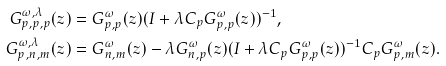Convert formula to latex. <formula><loc_0><loc_0><loc_500><loc_500>G ^ { \omega , \lambda } _ { p , p , p } ( z ) & = G ^ { \omega } _ { p , p } ( z ) ( I + \lambda C _ { p } G ^ { \omega } _ { p , p } ( z ) ) ^ { - 1 } , \\ G ^ { \omega , \lambda } _ { p , n , m } ( z ) & = G ^ { \omega } _ { n , m } ( z ) - \lambda G ^ { \omega } _ { n , p } ( z ) ( I + \lambda C _ { p } G ^ { \omega } _ { p , p } ( z ) ) ^ { - 1 } C _ { p } G ^ { \omega } _ { p , m } ( z ) .</formula> 